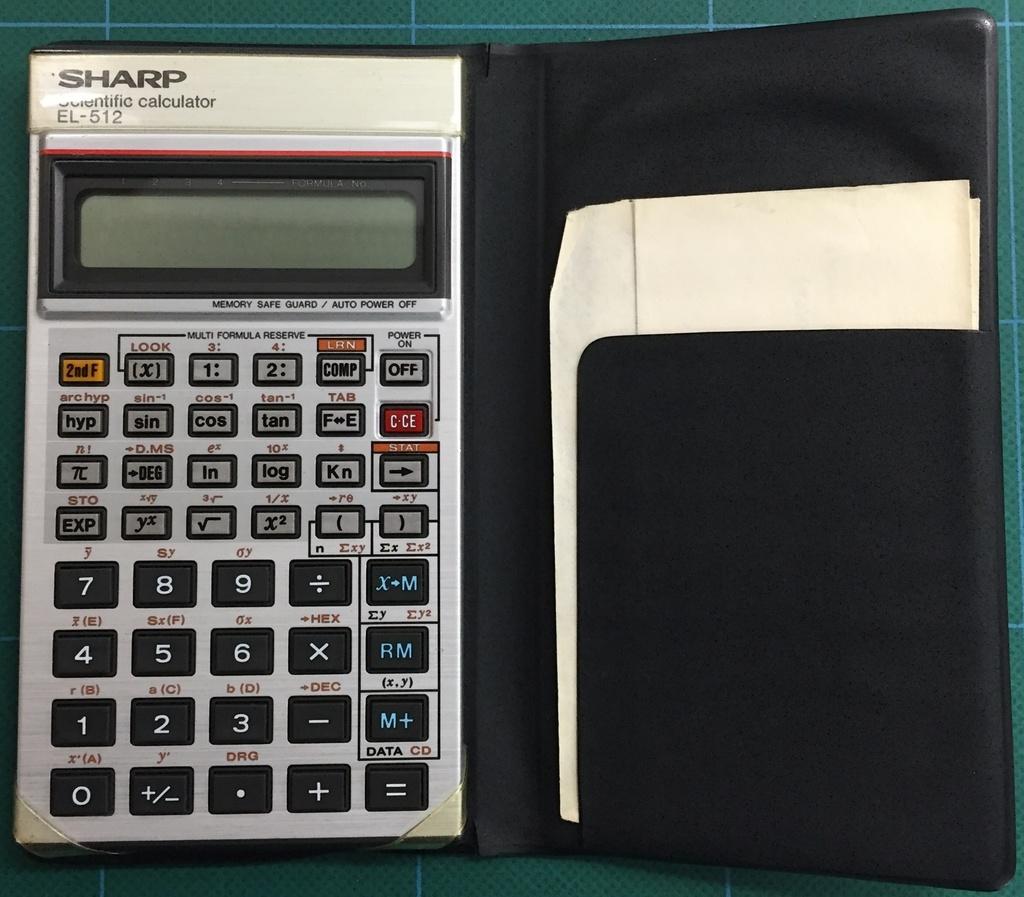What is the name of the calculator?
Your answer should be compact. Sharp. 